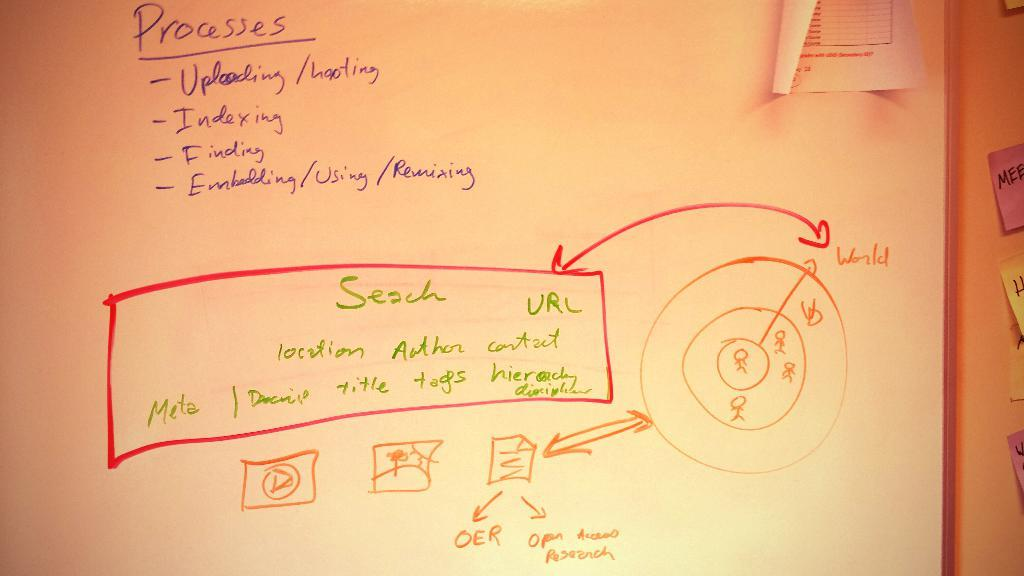<image>
Give a short and clear explanation of the subsequent image. A whiteboard has a box that says search and URL in it. 